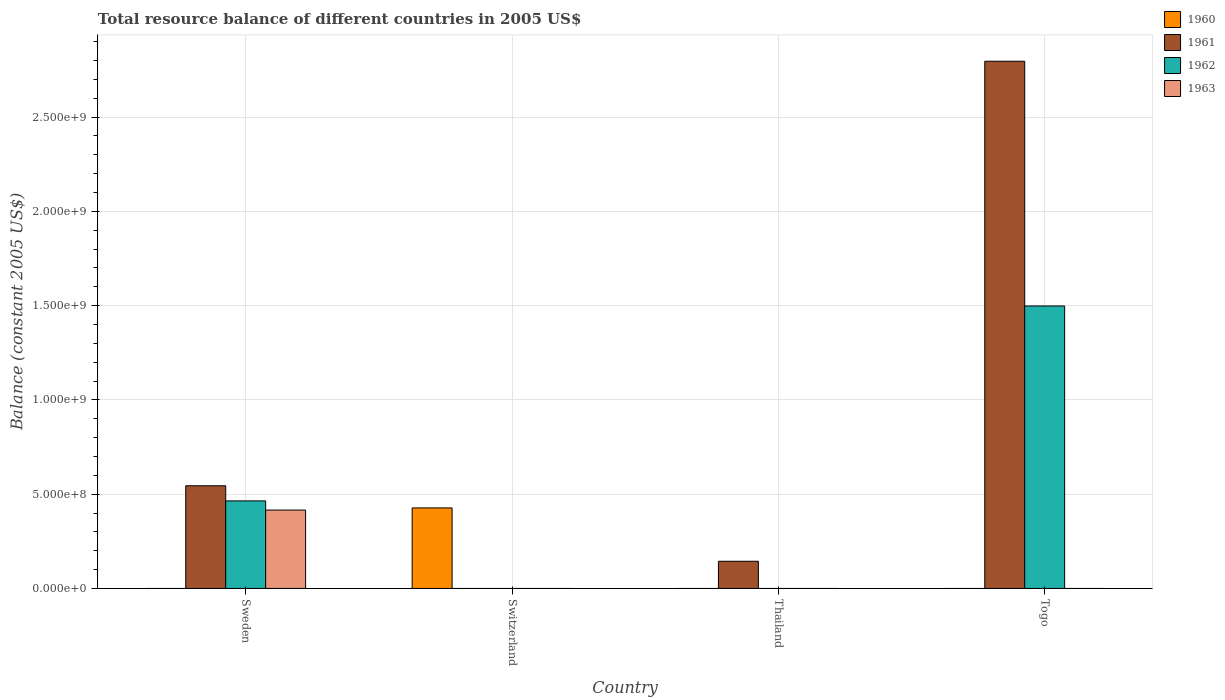What is the label of the 3rd group of bars from the left?
Provide a short and direct response. Thailand. In how many cases, is the number of bars for a given country not equal to the number of legend labels?
Your response must be concise. 4. What is the total resource balance in 1963 in Sweden?
Offer a terse response. 4.16e+08. Across all countries, what is the maximum total resource balance in 1962?
Your answer should be very brief. 1.50e+09. Across all countries, what is the minimum total resource balance in 1960?
Offer a terse response. 0. In which country was the total resource balance in 1961 maximum?
Give a very brief answer. Togo. What is the total total resource balance in 1960 in the graph?
Your answer should be compact. 4.27e+08. What is the difference between the total resource balance in 1960 in Togo and the total resource balance in 1961 in Thailand?
Provide a short and direct response. -1.44e+08. What is the average total resource balance in 1962 per country?
Ensure brevity in your answer.  4.91e+08. What is the difference between the total resource balance of/in 1962 and total resource balance of/in 1963 in Sweden?
Keep it short and to the point. 4.86e+07. What is the ratio of the total resource balance in 1962 in Sweden to that in Togo?
Your answer should be compact. 0.31. What is the difference between the highest and the second highest total resource balance in 1961?
Provide a succinct answer. 4.00e+08. What is the difference between the highest and the lowest total resource balance in 1961?
Provide a succinct answer. 2.80e+09. Are all the bars in the graph horizontal?
Offer a terse response. No. Does the graph contain any zero values?
Offer a terse response. Yes. Does the graph contain grids?
Offer a terse response. Yes. How are the legend labels stacked?
Provide a succinct answer. Vertical. What is the title of the graph?
Your answer should be compact. Total resource balance of different countries in 2005 US$. What is the label or title of the X-axis?
Provide a short and direct response. Country. What is the label or title of the Y-axis?
Ensure brevity in your answer.  Balance (constant 2005 US$). What is the Balance (constant 2005 US$) in 1960 in Sweden?
Make the answer very short. 0. What is the Balance (constant 2005 US$) of 1961 in Sweden?
Keep it short and to the point. 5.44e+08. What is the Balance (constant 2005 US$) of 1962 in Sweden?
Offer a very short reply. 4.64e+08. What is the Balance (constant 2005 US$) in 1963 in Sweden?
Keep it short and to the point. 4.16e+08. What is the Balance (constant 2005 US$) of 1960 in Switzerland?
Provide a succinct answer. 4.27e+08. What is the Balance (constant 2005 US$) in 1961 in Switzerland?
Ensure brevity in your answer.  0. What is the Balance (constant 2005 US$) of 1962 in Switzerland?
Give a very brief answer. 0. What is the Balance (constant 2005 US$) of 1960 in Thailand?
Offer a terse response. 0. What is the Balance (constant 2005 US$) of 1961 in Thailand?
Provide a succinct answer. 1.44e+08. What is the Balance (constant 2005 US$) in 1961 in Togo?
Give a very brief answer. 2.80e+09. What is the Balance (constant 2005 US$) in 1962 in Togo?
Your response must be concise. 1.50e+09. Across all countries, what is the maximum Balance (constant 2005 US$) in 1960?
Give a very brief answer. 4.27e+08. Across all countries, what is the maximum Balance (constant 2005 US$) in 1961?
Give a very brief answer. 2.80e+09. Across all countries, what is the maximum Balance (constant 2005 US$) of 1962?
Offer a terse response. 1.50e+09. Across all countries, what is the maximum Balance (constant 2005 US$) of 1963?
Offer a very short reply. 4.16e+08. Across all countries, what is the minimum Balance (constant 2005 US$) of 1961?
Offer a very short reply. 0. Across all countries, what is the minimum Balance (constant 2005 US$) of 1962?
Ensure brevity in your answer.  0. Across all countries, what is the minimum Balance (constant 2005 US$) in 1963?
Keep it short and to the point. 0. What is the total Balance (constant 2005 US$) of 1960 in the graph?
Your response must be concise. 4.27e+08. What is the total Balance (constant 2005 US$) of 1961 in the graph?
Keep it short and to the point. 3.48e+09. What is the total Balance (constant 2005 US$) in 1962 in the graph?
Offer a terse response. 1.96e+09. What is the total Balance (constant 2005 US$) of 1963 in the graph?
Your answer should be very brief. 4.16e+08. What is the difference between the Balance (constant 2005 US$) of 1961 in Sweden and that in Thailand?
Provide a short and direct response. 4.00e+08. What is the difference between the Balance (constant 2005 US$) of 1961 in Sweden and that in Togo?
Your response must be concise. -2.25e+09. What is the difference between the Balance (constant 2005 US$) in 1962 in Sweden and that in Togo?
Provide a short and direct response. -1.03e+09. What is the difference between the Balance (constant 2005 US$) of 1961 in Thailand and that in Togo?
Ensure brevity in your answer.  -2.65e+09. What is the difference between the Balance (constant 2005 US$) in 1961 in Sweden and the Balance (constant 2005 US$) in 1962 in Togo?
Ensure brevity in your answer.  -9.53e+08. What is the difference between the Balance (constant 2005 US$) of 1960 in Switzerland and the Balance (constant 2005 US$) of 1961 in Thailand?
Your answer should be compact. 2.83e+08. What is the difference between the Balance (constant 2005 US$) in 1960 in Switzerland and the Balance (constant 2005 US$) in 1961 in Togo?
Provide a short and direct response. -2.37e+09. What is the difference between the Balance (constant 2005 US$) in 1960 in Switzerland and the Balance (constant 2005 US$) in 1962 in Togo?
Offer a terse response. -1.07e+09. What is the difference between the Balance (constant 2005 US$) in 1961 in Thailand and the Balance (constant 2005 US$) in 1962 in Togo?
Offer a terse response. -1.35e+09. What is the average Balance (constant 2005 US$) in 1960 per country?
Make the answer very short. 1.07e+08. What is the average Balance (constant 2005 US$) of 1961 per country?
Provide a succinct answer. 8.71e+08. What is the average Balance (constant 2005 US$) in 1962 per country?
Your response must be concise. 4.91e+08. What is the average Balance (constant 2005 US$) in 1963 per country?
Offer a terse response. 1.04e+08. What is the difference between the Balance (constant 2005 US$) in 1961 and Balance (constant 2005 US$) in 1962 in Sweden?
Your answer should be very brief. 8.03e+07. What is the difference between the Balance (constant 2005 US$) of 1961 and Balance (constant 2005 US$) of 1963 in Sweden?
Ensure brevity in your answer.  1.29e+08. What is the difference between the Balance (constant 2005 US$) of 1962 and Balance (constant 2005 US$) of 1963 in Sweden?
Your response must be concise. 4.86e+07. What is the difference between the Balance (constant 2005 US$) of 1961 and Balance (constant 2005 US$) of 1962 in Togo?
Ensure brevity in your answer.  1.30e+09. What is the ratio of the Balance (constant 2005 US$) in 1961 in Sweden to that in Thailand?
Offer a terse response. 3.78. What is the ratio of the Balance (constant 2005 US$) of 1961 in Sweden to that in Togo?
Your response must be concise. 0.19. What is the ratio of the Balance (constant 2005 US$) of 1962 in Sweden to that in Togo?
Offer a terse response. 0.31. What is the ratio of the Balance (constant 2005 US$) of 1961 in Thailand to that in Togo?
Keep it short and to the point. 0.05. What is the difference between the highest and the second highest Balance (constant 2005 US$) of 1961?
Your answer should be compact. 2.25e+09. What is the difference between the highest and the lowest Balance (constant 2005 US$) in 1960?
Offer a very short reply. 4.27e+08. What is the difference between the highest and the lowest Balance (constant 2005 US$) of 1961?
Make the answer very short. 2.80e+09. What is the difference between the highest and the lowest Balance (constant 2005 US$) in 1962?
Your answer should be very brief. 1.50e+09. What is the difference between the highest and the lowest Balance (constant 2005 US$) in 1963?
Your answer should be compact. 4.16e+08. 